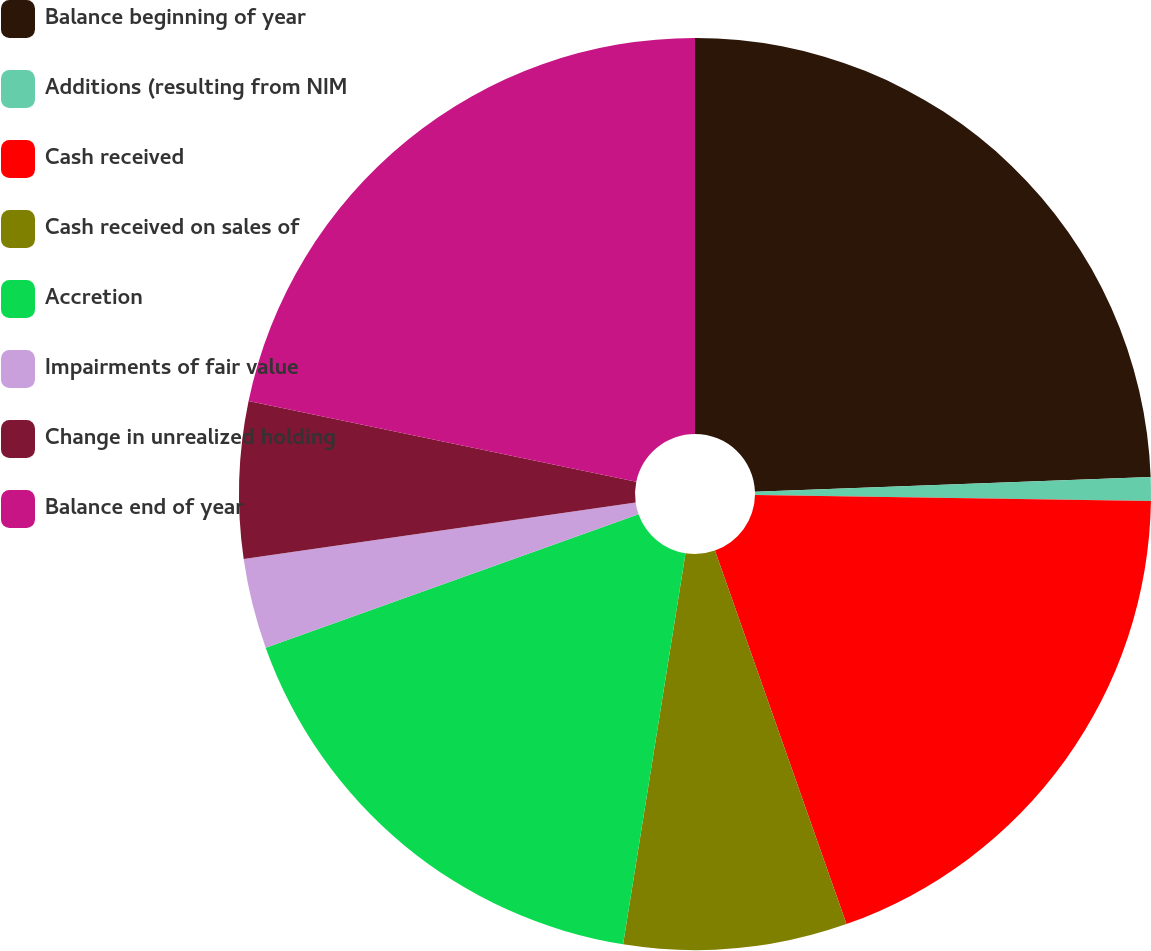<chart> <loc_0><loc_0><loc_500><loc_500><pie_chart><fcel>Balance beginning of year<fcel>Additions (resulting from NIM<fcel>Cash received<fcel>Cash received on sales of<fcel>Accretion<fcel>Impairments of fair value<fcel>Change in unrealized holding<fcel>Balance end of year<nl><fcel>24.41%<fcel>0.83%<fcel>19.37%<fcel>7.91%<fcel>17.01%<fcel>3.19%<fcel>5.55%<fcel>21.73%<nl></chart> 